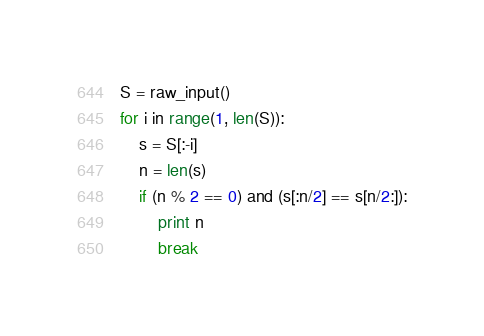<code> <loc_0><loc_0><loc_500><loc_500><_Python_>S = raw_input()
for i in range(1, len(S)):
    s = S[:-i]
    n = len(s)
    if (n % 2 == 0) and (s[:n/2] == s[n/2:]):
        print n
        break</code> 